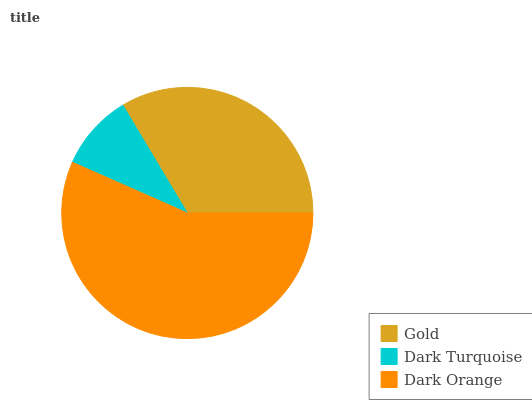Is Dark Turquoise the minimum?
Answer yes or no. Yes. Is Dark Orange the maximum?
Answer yes or no. Yes. Is Dark Orange the minimum?
Answer yes or no. No. Is Dark Turquoise the maximum?
Answer yes or no. No. Is Dark Orange greater than Dark Turquoise?
Answer yes or no. Yes. Is Dark Turquoise less than Dark Orange?
Answer yes or no. Yes. Is Dark Turquoise greater than Dark Orange?
Answer yes or no. No. Is Dark Orange less than Dark Turquoise?
Answer yes or no. No. Is Gold the high median?
Answer yes or no. Yes. Is Gold the low median?
Answer yes or no. Yes. Is Dark Turquoise the high median?
Answer yes or no. No. Is Dark Orange the low median?
Answer yes or no. No. 